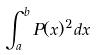Convert formula to latex. <formula><loc_0><loc_0><loc_500><loc_500>\int _ { a } ^ { b } P ( x ) ^ { 2 } d x</formula> 